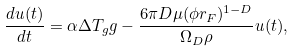Convert formula to latex. <formula><loc_0><loc_0><loc_500><loc_500>\frac { d u ( t ) } { d t } = \alpha \Delta T _ { g } g - \frac { 6 \pi D \mu ( \phi r _ { F } ) ^ { 1 - D } } { \Omega _ { D } \rho } u ( t ) ,</formula> 